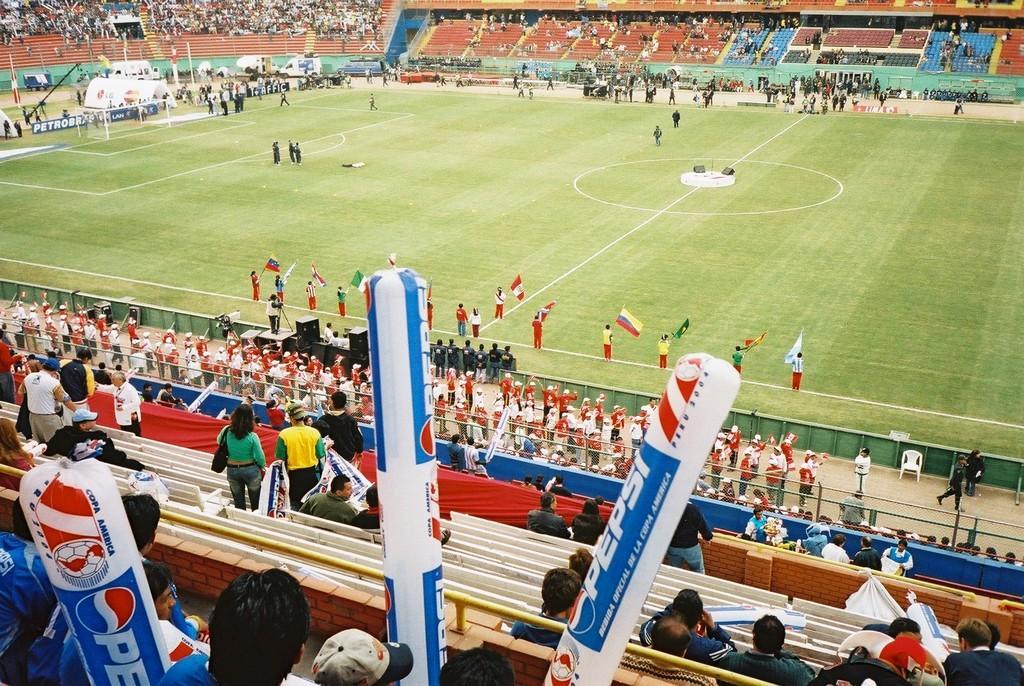Please provide a concise description of this image. In this image, we can see few people are on the ground. Few people are holding flags, some objects. Few people are sitting, standing and walking. Here we can see stairs, hoardings, rods. 